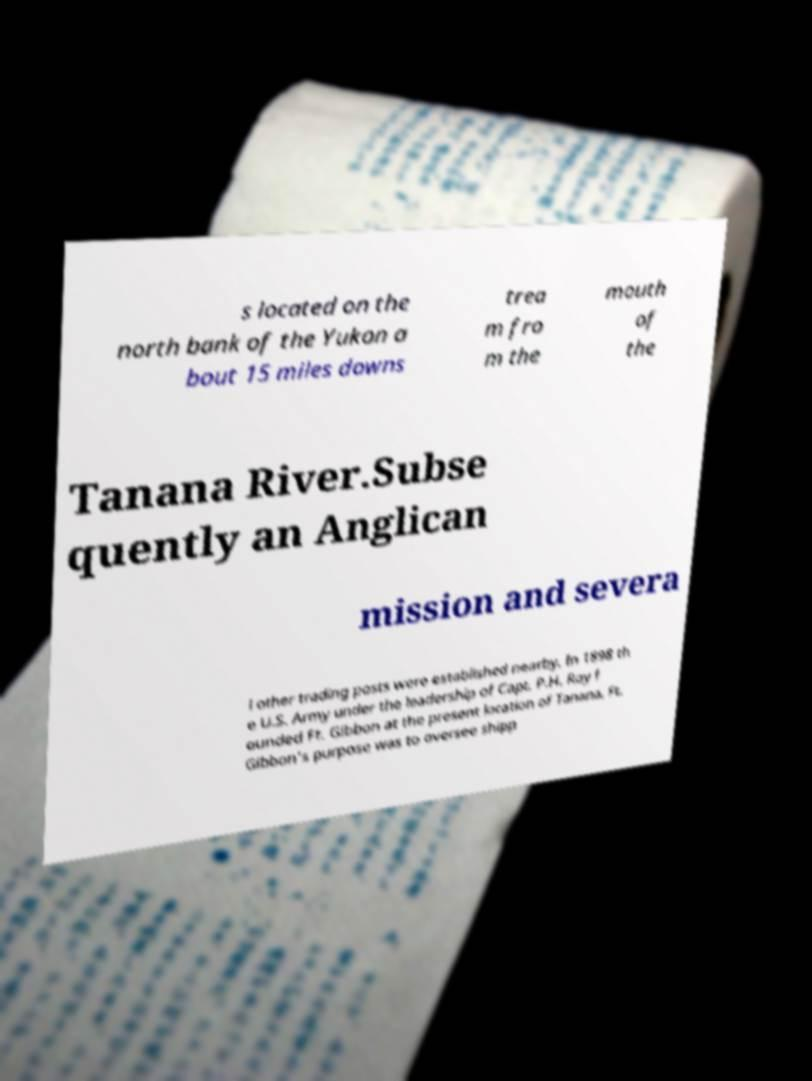For documentation purposes, I need the text within this image transcribed. Could you provide that? s located on the north bank of the Yukon a bout 15 miles downs trea m fro m the mouth of the Tanana River.Subse quently an Anglican mission and severa l other trading posts were established nearby. In 1898 th e U.S. Army under the leadership of Capt. P.H. Ray f ounded Ft. Gibbon at the present location of Tanana. Ft. Gibbon's purpose was to oversee shipp 